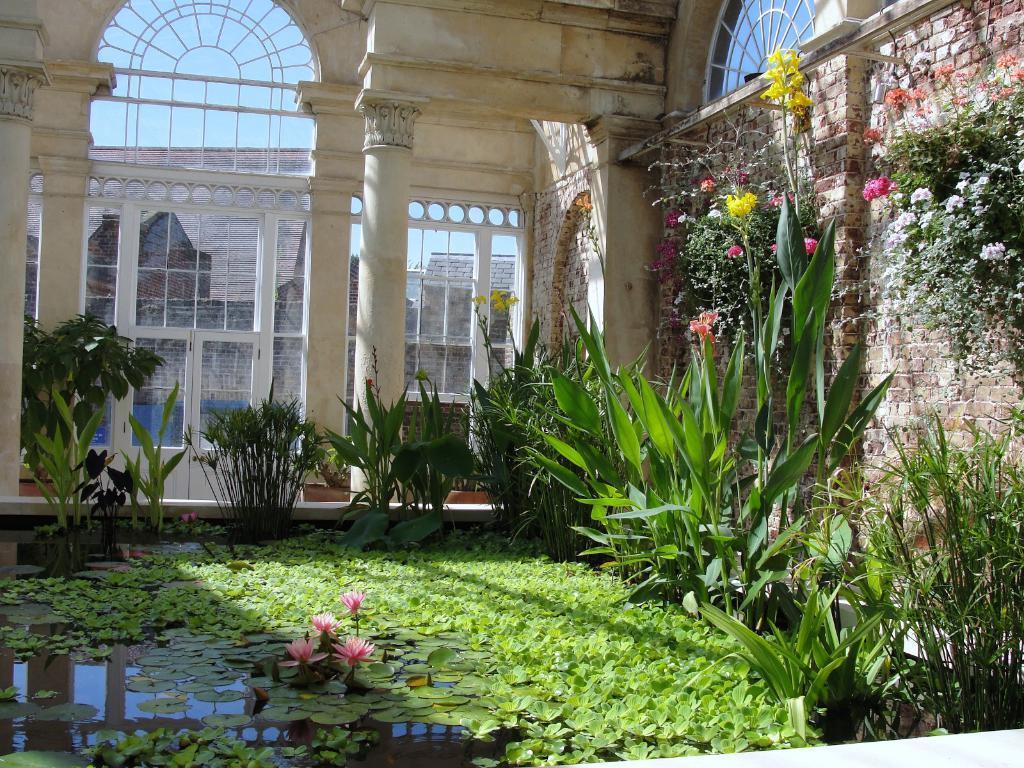Please provide a concise description of this image. In this image there are leaves and flowers on the water, plants, buildings, and in the background there is sky. 